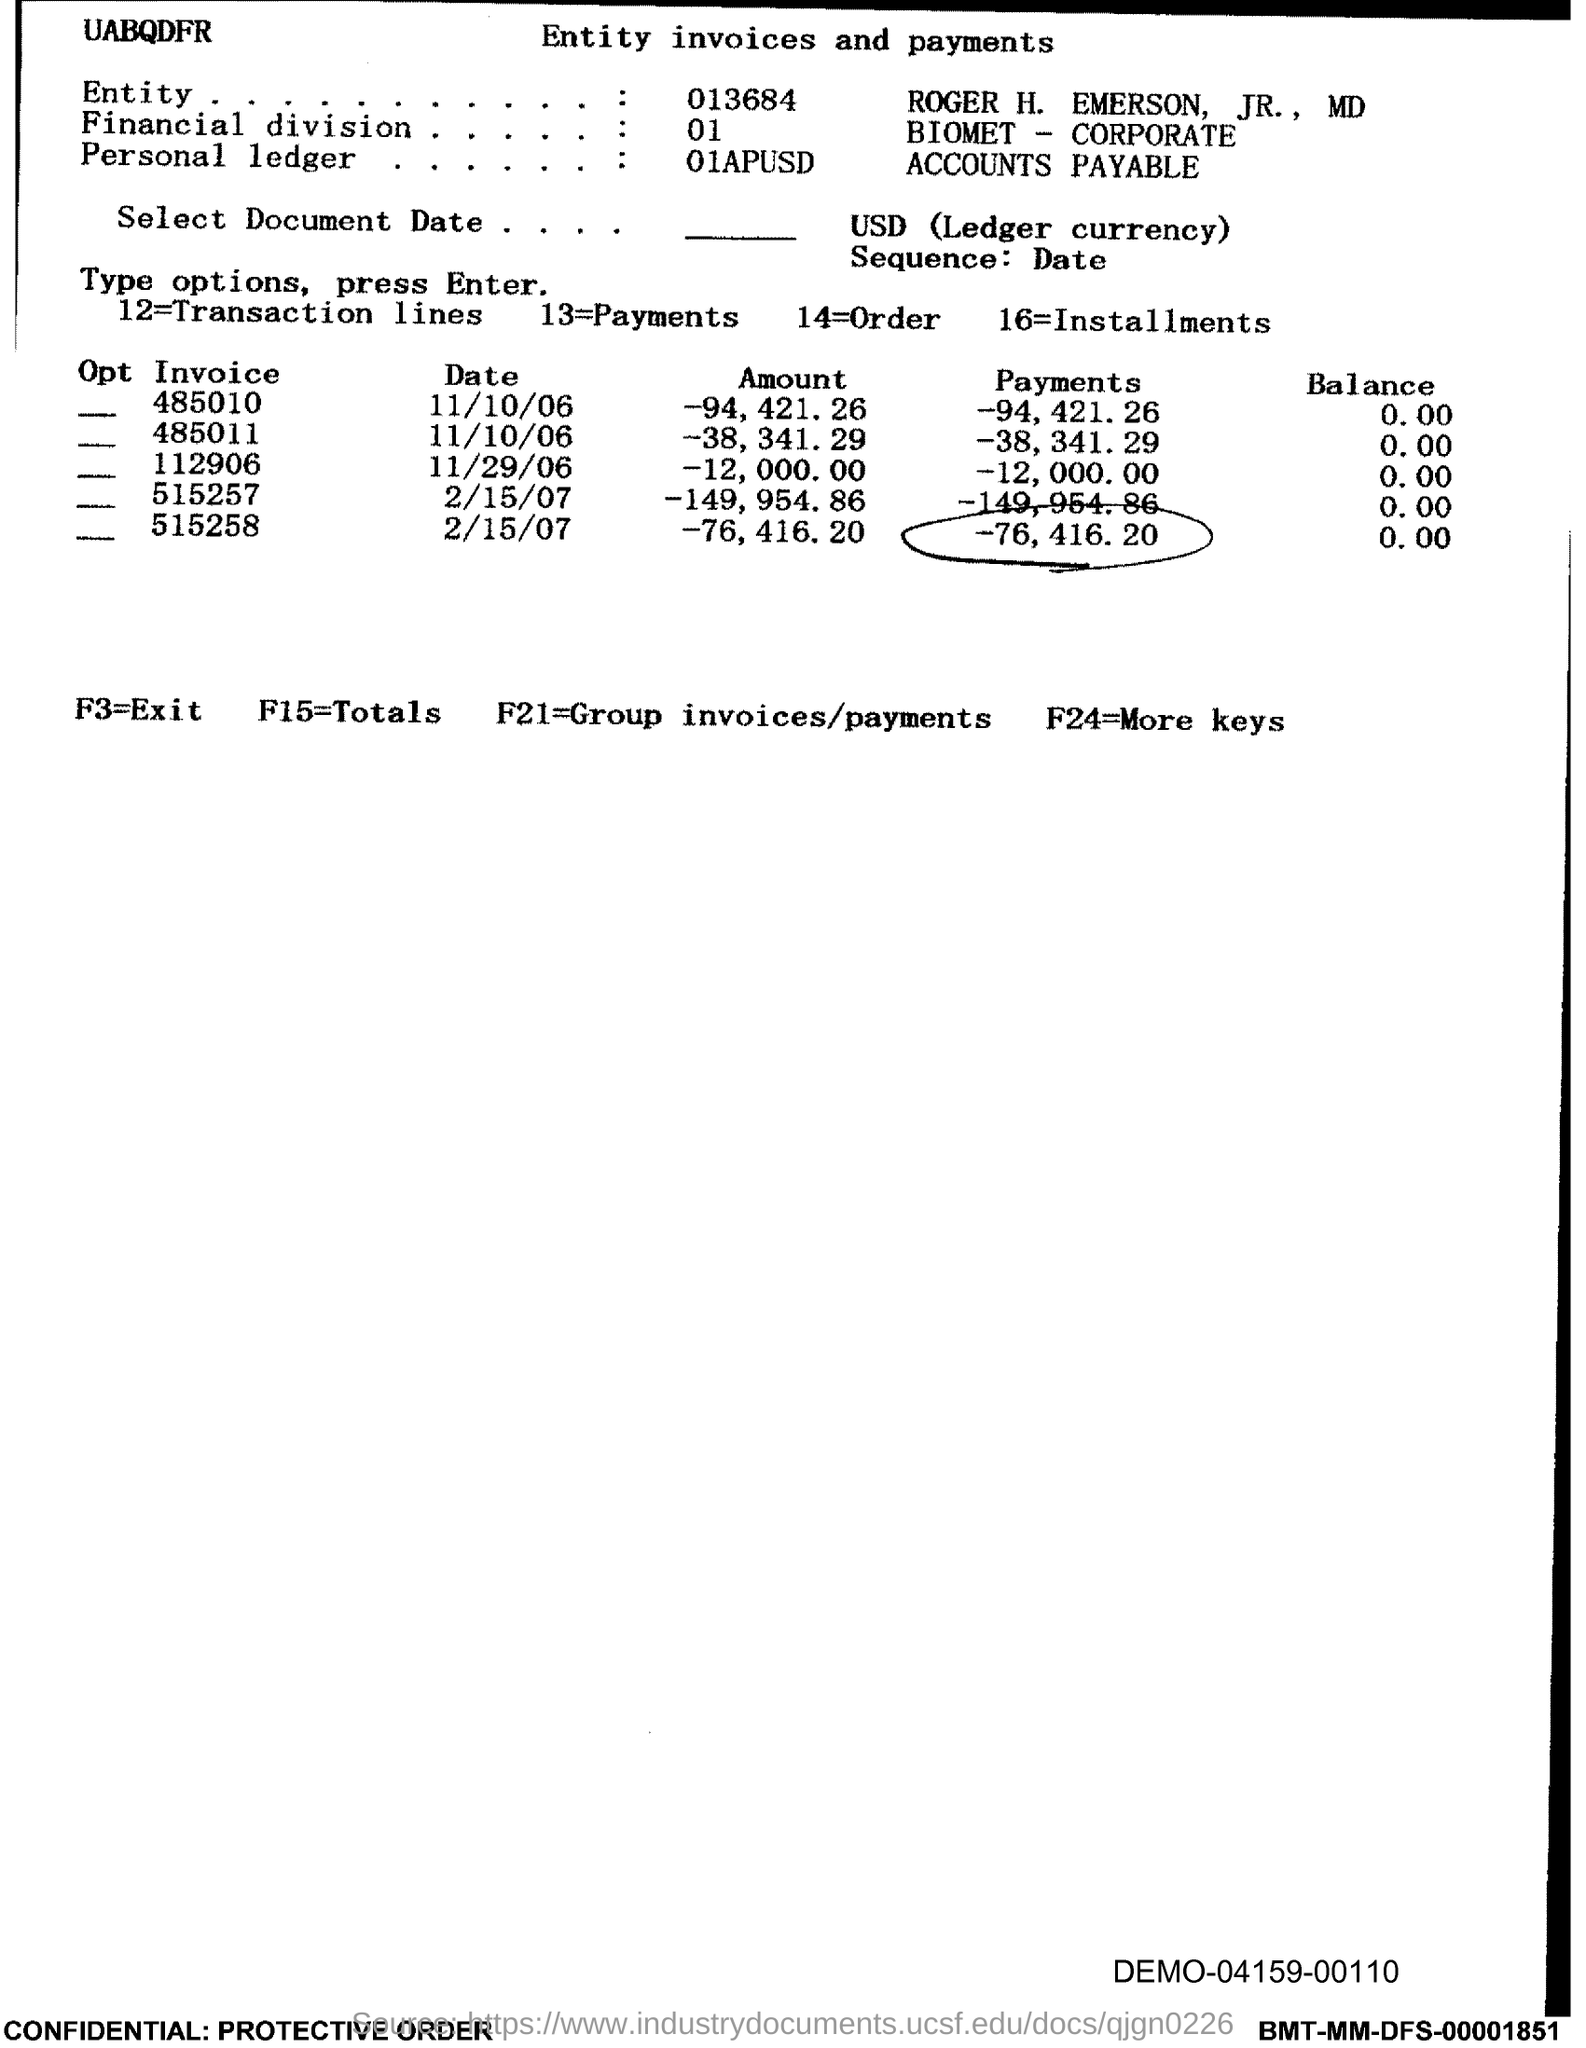What is f3 =?
Your answer should be compact. Exit. What is f15=?
Offer a terse response. Totals. What is f24 =?
Your response must be concise. More keys. 